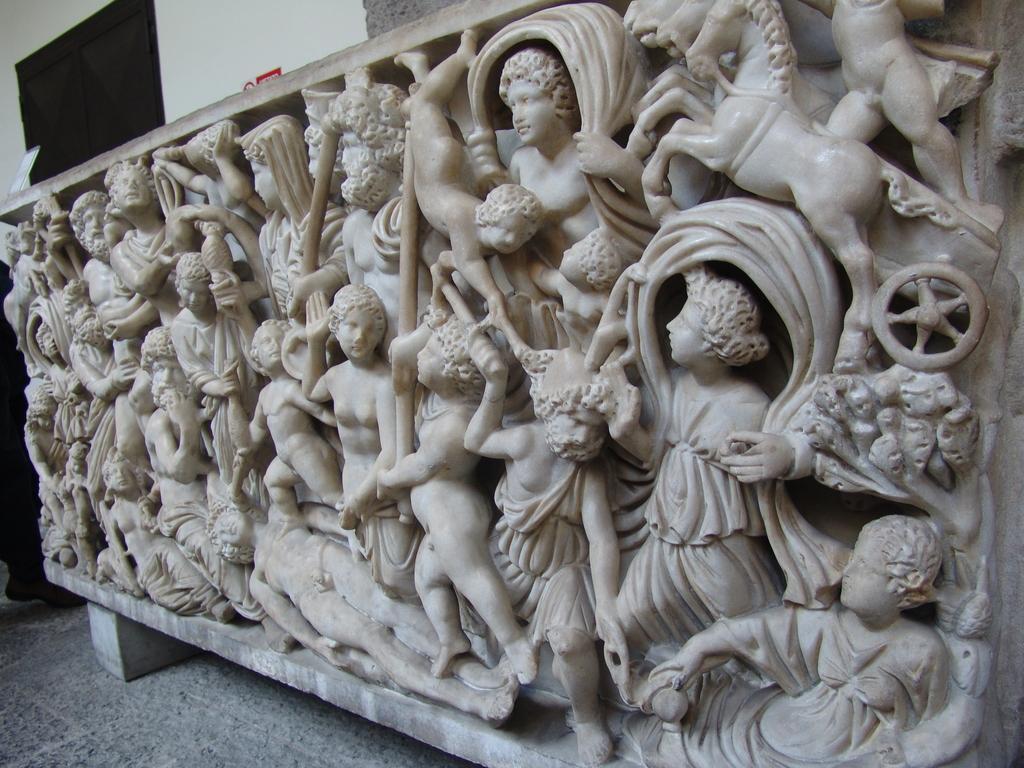Can you describe this image briefly? There are sculptures in the foreground, it seems like a person and a door in the background area. 